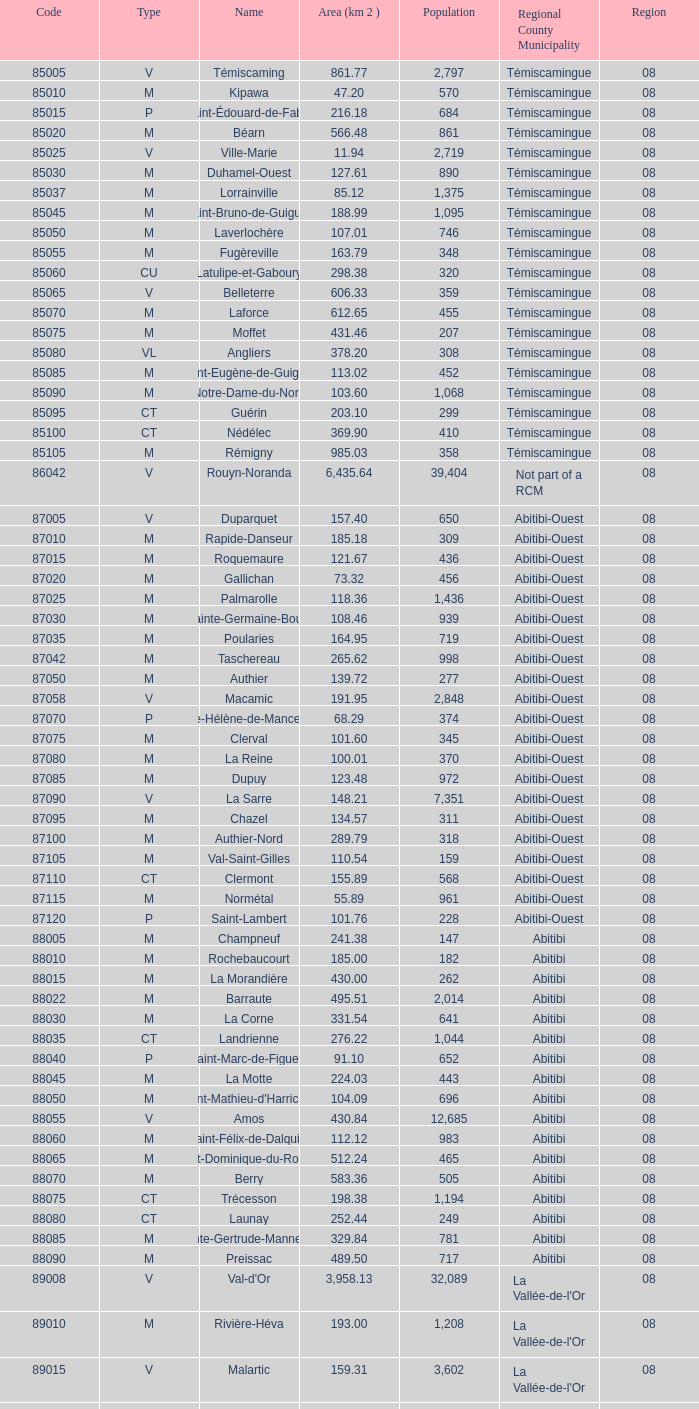What is the km2 area for the population of 311? 134.57. 